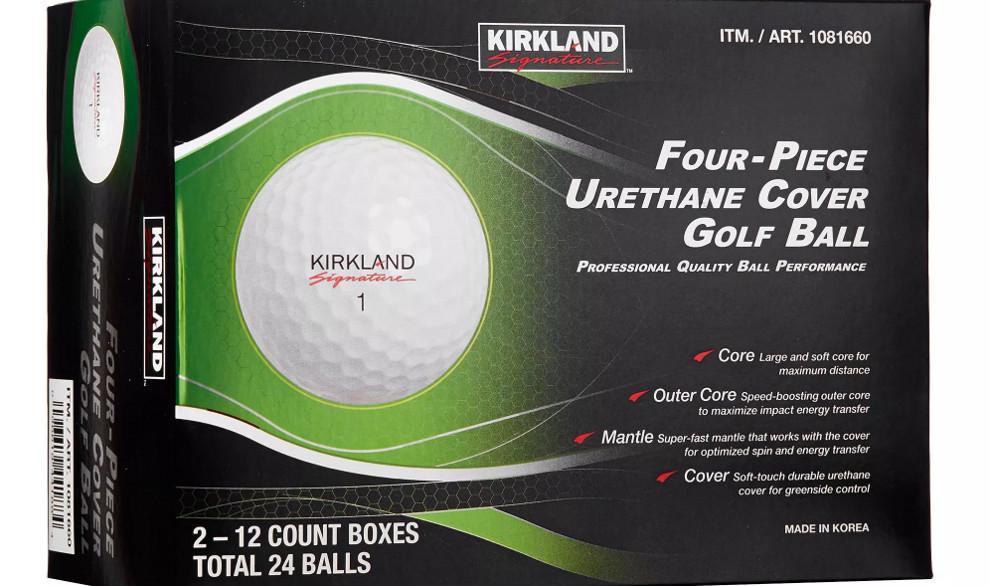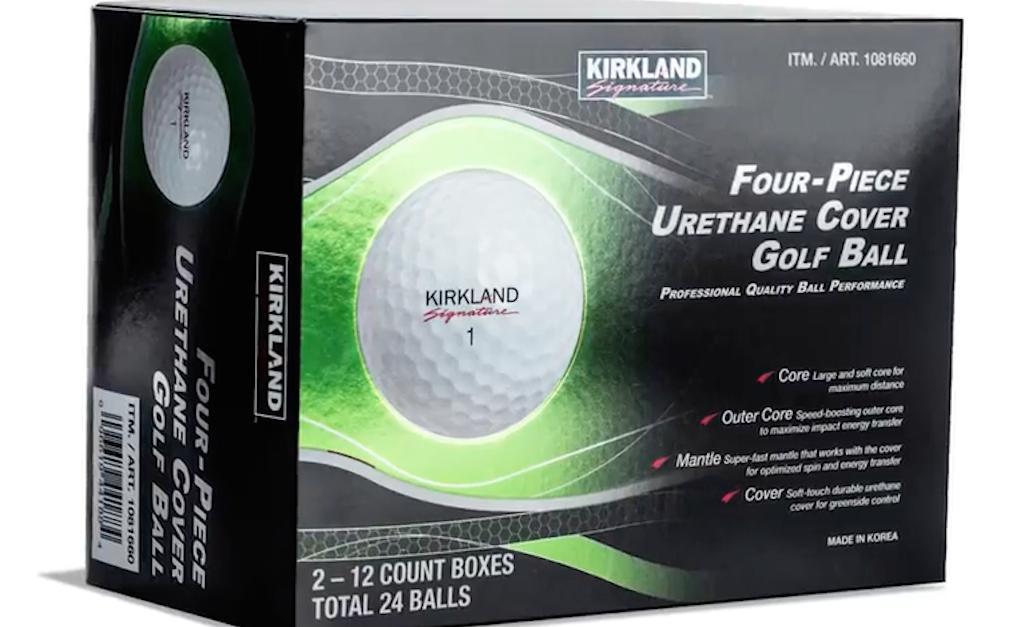The first image is the image on the left, the second image is the image on the right. For the images shown, is this caption "At least one image includes a golf ball that is not in a package in front of golf balls in a package." true? Answer yes or no. No. The first image is the image on the left, the second image is the image on the right. Examine the images to the left and right. Is the description "Two golf balls are not in a box." accurate? Answer yes or no. No. 